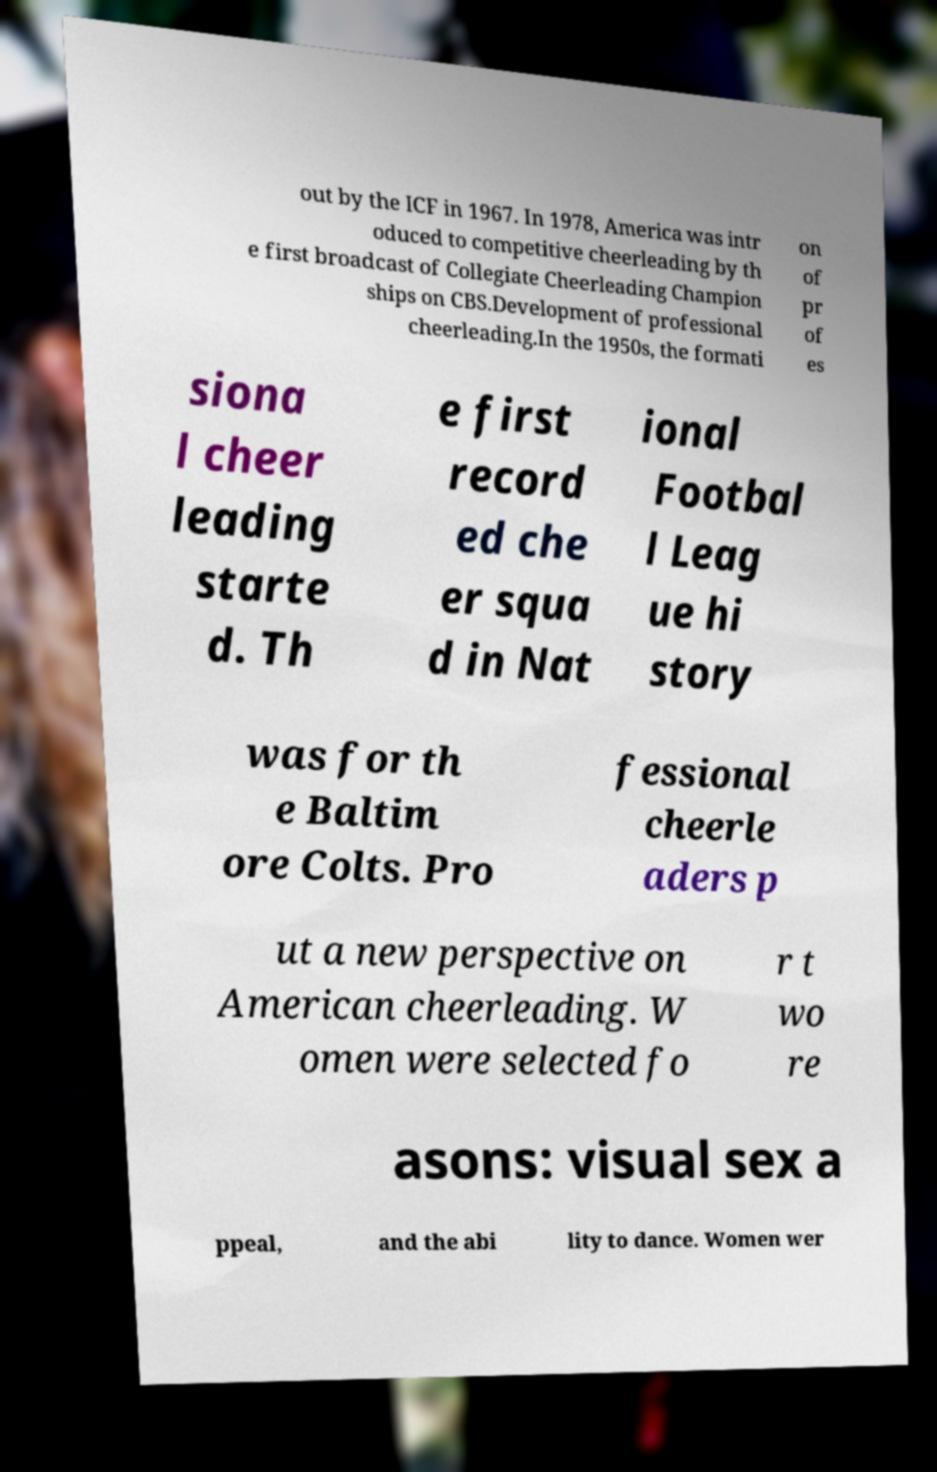Can you accurately transcribe the text from the provided image for me? out by the ICF in 1967. In 1978, America was intr oduced to competitive cheerleading by th e first broadcast of Collegiate Cheerleading Champion ships on CBS.Development of professional cheerleading.In the 1950s, the formati on of pr of es siona l cheer leading starte d. Th e first record ed che er squa d in Nat ional Footbal l Leag ue hi story was for th e Baltim ore Colts. Pro fessional cheerle aders p ut a new perspective on American cheerleading. W omen were selected fo r t wo re asons: visual sex a ppeal, and the abi lity to dance. Women wer 